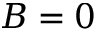<formula> <loc_0><loc_0><loc_500><loc_500>B = 0</formula> 